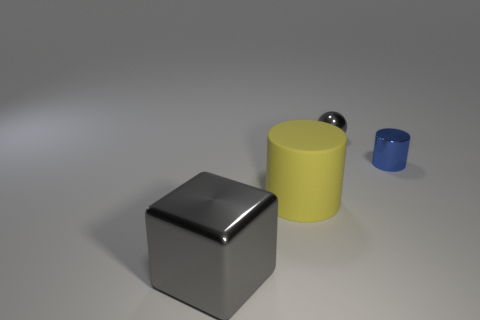There is a metal object that is behind the big gray metallic object and in front of the tiny shiny ball; how big is it?
Offer a very short reply. Small. There is a object that is both behind the gray shiny block and left of the gray metallic ball; what is its color?
Provide a succinct answer. Yellow. Is the number of small blue metal things behind the small metallic ball less than the number of tiny objects left of the yellow cylinder?
Make the answer very short. No. What number of gray shiny objects are the same shape as the blue metal object?
Give a very brief answer. 0. The blue cylinder that is made of the same material as the tiny gray object is what size?
Offer a terse response. Small. There is a tiny thing that is left of the small object that is in front of the gray shiny ball; what is its color?
Provide a short and direct response. Gray. Do the large yellow rubber thing and the small metallic object on the left side of the blue shiny cylinder have the same shape?
Offer a very short reply. No. How many shiny cubes have the same size as the metallic ball?
Make the answer very short. 0. What material is the small blue thing that is the same shape as the yellow matte thing?
Ensure brevity in your answer.  Metal. Is the color of the cylinder that is in front of the tiny shiny cylinder the same as the object to the right of the small gray metal ball?
Ensure brevity in your answer.  No. 